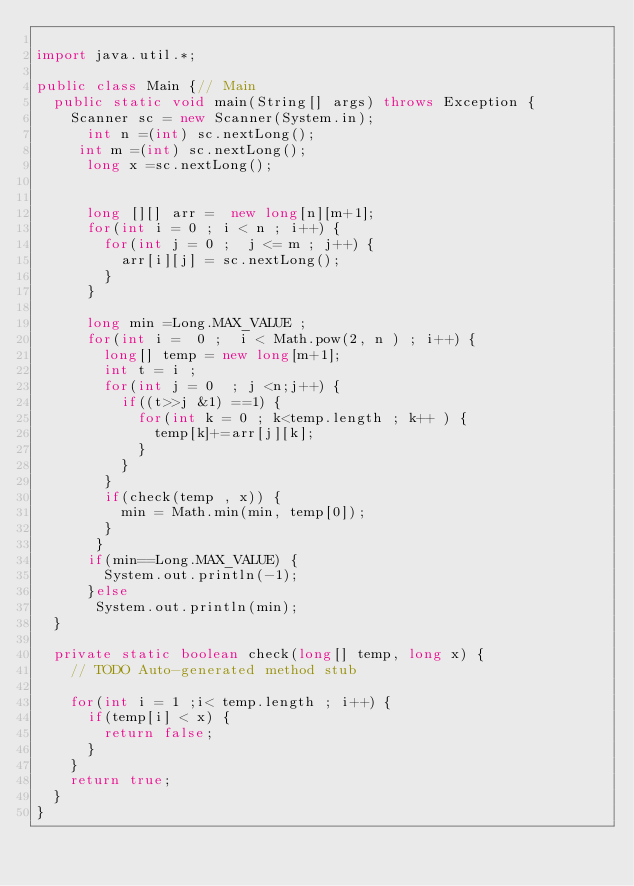Convert code to text. <code><loc_0><loc_0><loc_500><loc_500><_Java_>
import java.util.*;

public class Main {// Main
	public static void main(String[] args) throws Exception {
		Scanner sc = new Scanner(System.in);
      int n =(int) sc.nextLong();
     int m =(int) sc.nextLong();
      long x =sc.nextLong();
      
      
      long [][] arr =  new long[n][m+1];
      for(int i = 0 ; i < n ; i++) {
    	  for(int j = 0 ;  j <= m ; j++) {
    		  arr[i][j] = sc.nextLong();
    	  }
      }
     
      long min =Long.MAX_VALUE ;
      for(int i =  0 ;  i < Math.pow(2, n ) ; i++) {
    	  long[] temp = new long[m+1];
    	  int t = i ;
    	  for(int j = 0  ; j <n;j++) {
    		  if((t>>j &1) ==1) {
    			  for(int k = 0 ; k<temp.length ; k++ ) {
    				  temp[k]+=arr[j][k];
    			  }
    		  }
    	  }
    	  if(check(temp , x)) {
    		  min = Math.min(min, temp[0]);
    	  }
       }
      if(min==Long.MAX_VALUE) {
    	  System.out.println(-1);
      }else
       System.out.println(min);
	}

	private static boolean check(long[] temp, long x) {
		// TODO Auto-generated method stub
		 
		for(int i = 1 ;i< temp.length ; i++) {
			if(temp[i] < x) {
				return false;
			}
		}
		return true;
	}
}</code> 